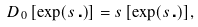<formula> <loc_0><loc_0><loc_500><loc_500>\ D _ { 0 } \, [ \exp ( s \, \centerdot ) ] = s \, [ \exp ( s \, \centerdot ) ] ,</formula> 